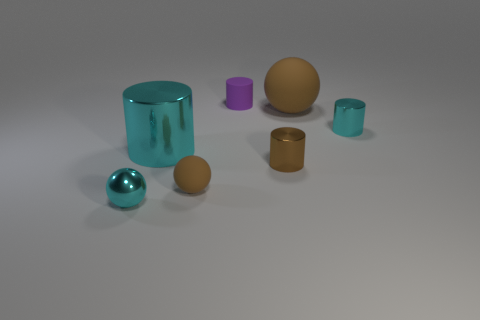What can you infer about the sizes of the objects relative to each other? The objects vary in size, with the teal-blue cylinder being the largest in the image, followed by the mustard-brown sphere. The smallest objects are the metallic teal-blue sphere and the small teal-blue cylinder. Do any of these objects appear to be grouped together in some way? Yes, the teal-blue sphere and cylinder are in close proximity and share similar color tones, which suggests they have been deliberately paired. Additionally, the golden cylinder and the mustard-brown sphere are close to each other, complementing each other's matte finish. 